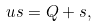Convert formula to latex. <formula><loc_0><loc_0><loc_500><loc_500>\ u s = Q + s ,</formula> 